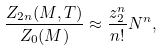Convert formula to latex. <formula><loc_0><loc_0><loc_500><loc_500>\frac { Z _ { 2 n } ( M , T ) } { Z _ { 0 } ( M ) } \approx \frac { z _ { 2 } ^ { n } } { n ! } N ^ { n } ,</formula> 